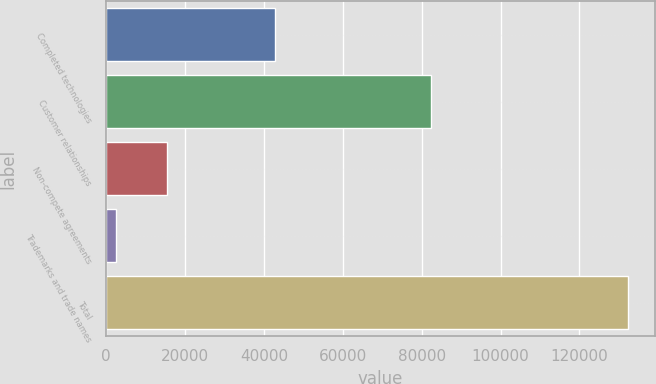Convert chart. <chart><loc_0><loc_0><loc_500><loc_500><bar_chart><fcel>Completed technologies<fcel>Customer relationships<fcel>Non-compete agreements<fcel>Trademarks and trade names<fcel>Total<nl><fcel>42794<fcel>82440<fcel>15502<fcel>2512<fcel>132412<nl></chart> 